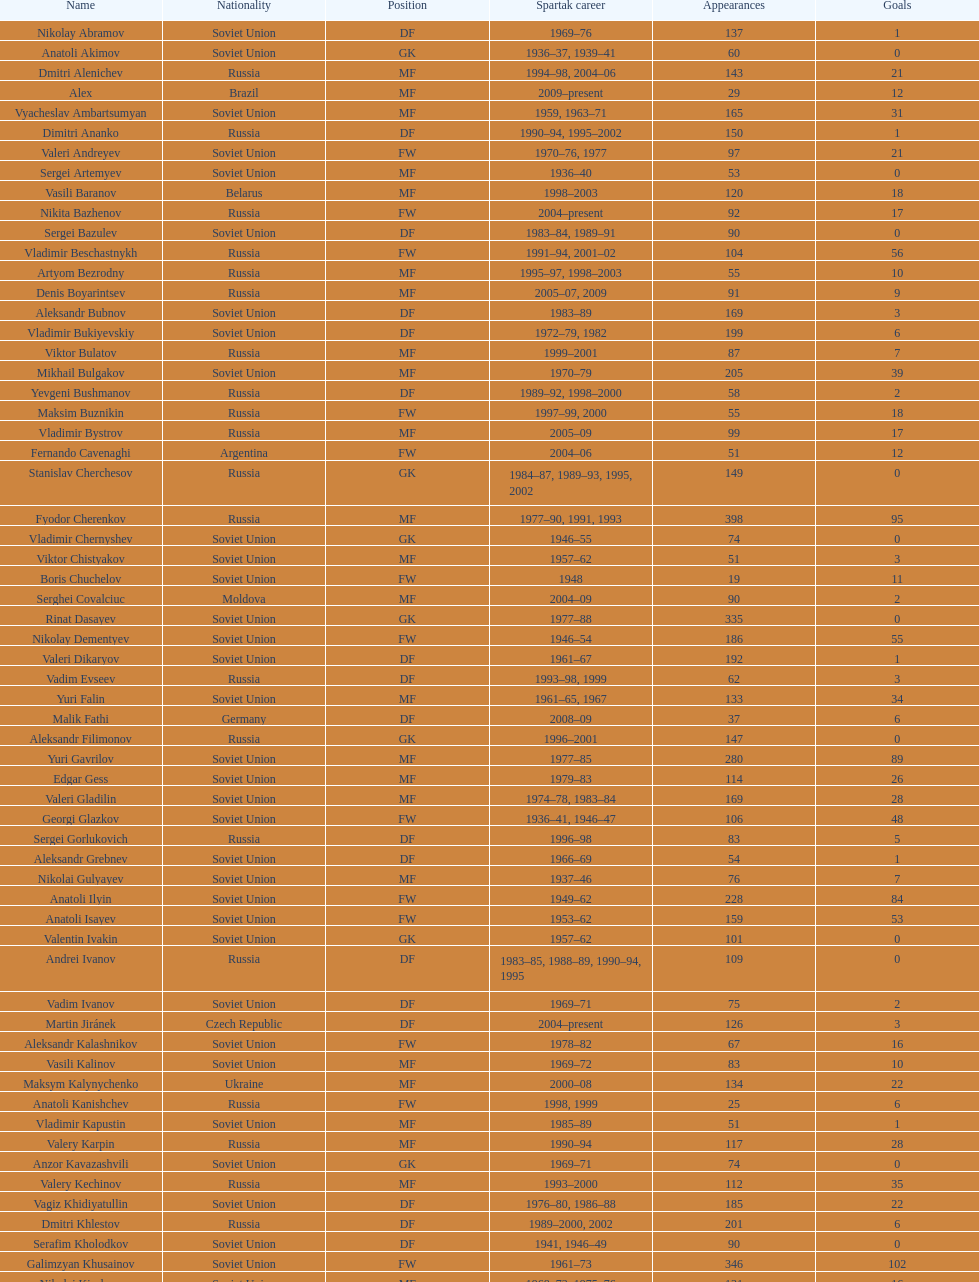Vladimir bukiyevskiy made how many showings? 199. 